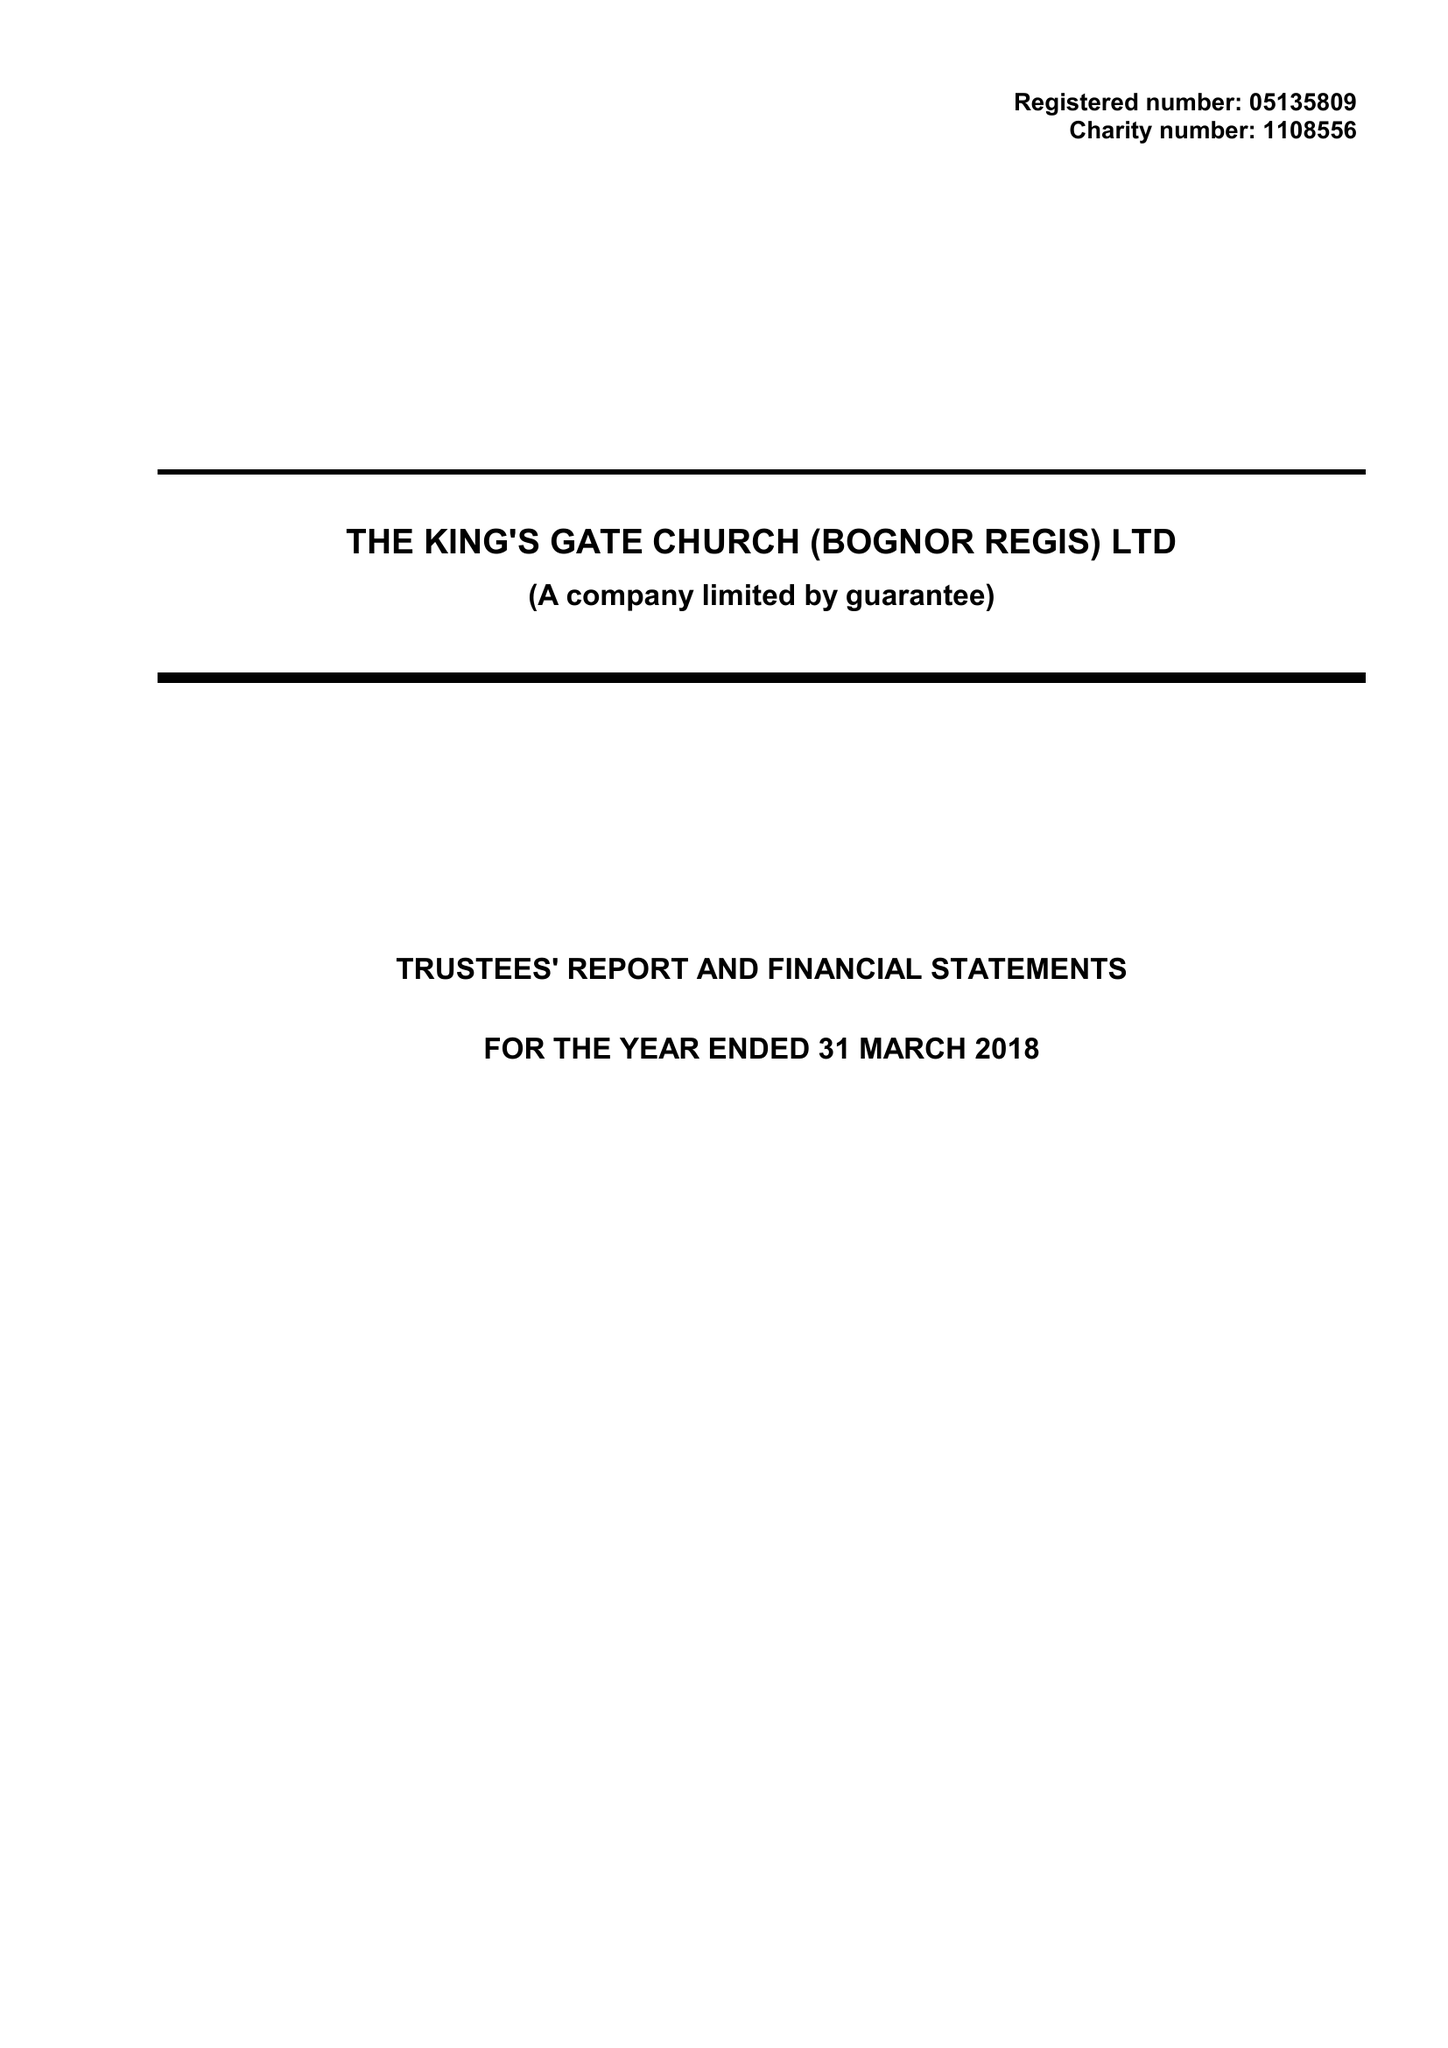What is the value for the charity_name?
Answer the question using a single word or phrase. The King's Gate Church (Bognor Regis) Ltd. 